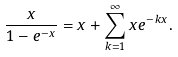<formula> <loc_0><loc_0><loc_500><loc_500>\frac { x } { 1 - e ^ { - x } } = x + \sum _ { k = 1 } ^ { \infty } x e ^ { - k x } .</formula> 